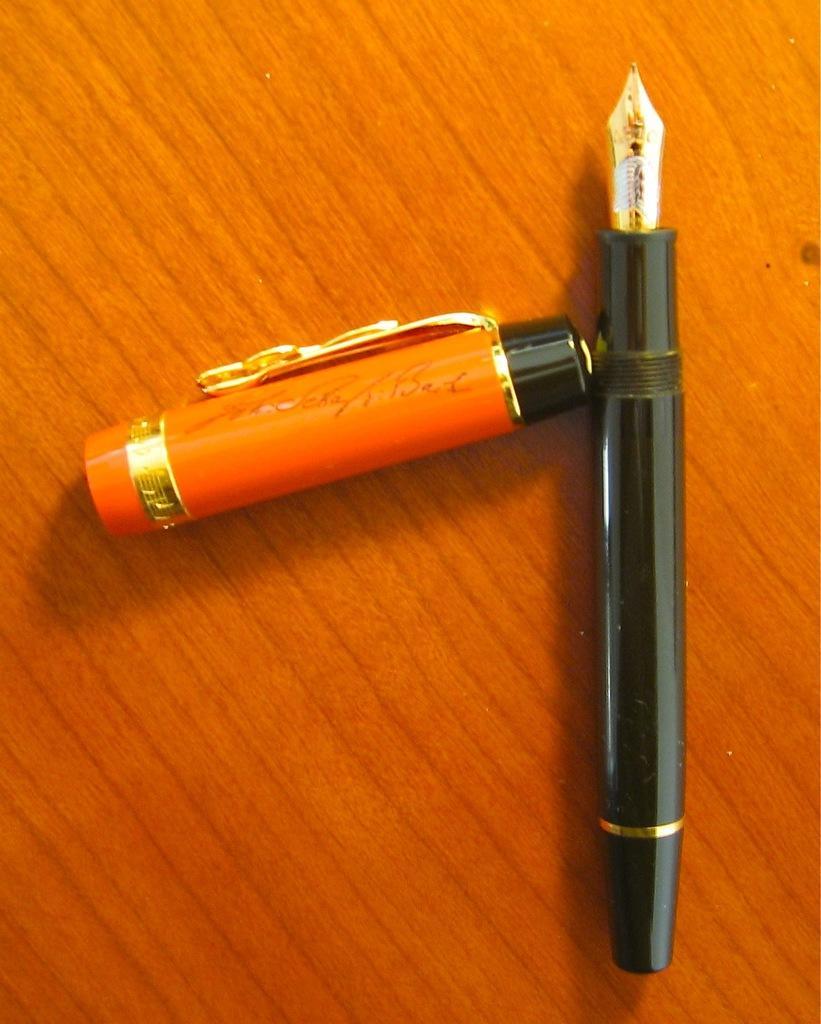Please provide a concise description of this image. In this image there is a pen in the center and there is a cap of the pen with some text written on it. 